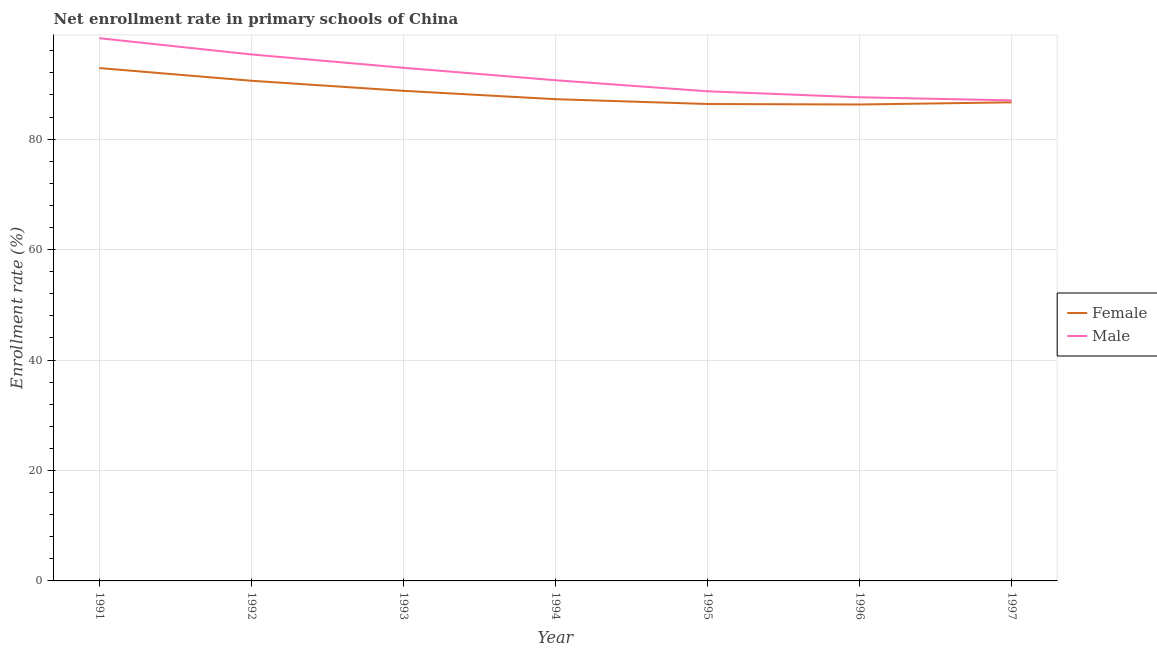How many different coloured lines are there?
Your response must be concise. 2. Does the line corresponding to enrollment rate of female students intersect with the line corresponding to enrollment rate of male students?
Give a very brief answer. No. What is the enrollment rate of female students in 1991?
Keep it short and to the point. 92.88. Across all years, what is the maximum enrollment rate of male students?
Your response must be concise. 98.29. Across all years, what is the minimum enrollment rate of female students?
Keep it short and to the point. 86.28. In which year was the enrollment rate of male students maximum?
Give a very brief answer. 1991. What is the total enrollment rate of female students in the graph?
Offer a very short reply. 618.77. What is the difference between the enrollment rate of female students in 1994 and that in 1996?
Provide a succinct answer. 0.97. What is the difference between the enrollment rate of male students in 1994 and the enrollment rate of female students in 1997?
Your answer should be very brief. 4. What is the average enrollment rate of male students per year?
Make the answer very short. 91.5. In the year 1996, what is the difference between the enrollment rate of female students and enrollment rate of male students?
Your answer should be very brief. -1.31. In how many years, is the enrollment rate of female students greater than 48 %?
Your answer should be very brief. 7. What is the ratio of the enrollment rate of female students in 1991 to that in 1992?
Your answer should be very brief. 1.03. Is the enrollment rate of female students in 1996 less than that in 1997?
Give a very brief answer. Yes. Is the difference between the enrollment rate of male students in 1991 and 1995 greater than the difference between the enrollment rate of female students in 1991 and 1995?
Your answer should be very brief. Yes. What is the difference between the highest and the second highest enrollment rate of female students?
Provide a succinct answer. 2.3. What is the difference between the highest and the lowest enrollment rate of female students?
Your answer should be compact. 6.6. In how many years, is the enrollment rate of male students greater than the average enrollment rate of male students taken over all years?
Make the answer very short. 3. Is the sum of the enrollment rate of male students in 1993 and 1996 greater than the maximum enrollment rate of female students across all years?
Provide a short and direct response. Yes. Does the enrollment rate of male students monotonically increase over the years?
Make the answer very short. No. Is the enrollment rate of female students strictly greater than the enrollment rate of male students over the years?
Your answer should be compact. No. How many lines are there?
Ensure brevity in your answer.  2. How many years are there in the graph?
Your answer should be very brief. 7. What is the difference between two consecutive major ticks on the Y-axis?
Your response must be concise. 20. Does the graph contain grids?
Provide a short and direct response. Yes. How are the legend labels stacked?
Keep it short and to the point. Vertical. What is the title of the graph?
Your answer should be very brief. Net enrollment rate in primary schools of China. Does "Highest 10% of population" appear as one of the legend labels in the graph?
Give a very brief answer. No. What is the label or title of the X-axis?
Your answer should be very brief. Year. What is the label or title of the Y-axis?
Give a very brief answer. Enrollment rate (%). What is the Enrollment rate (%) of Female in 1991?
Make the answer very short. 92.88. What is the Enrollment rate (%) in Male in 1991?
Give a very brief answer. 98.29. What is the Enrollment rate (%) of Female in 1992?
Make the answer very short. 90.58. What is the Enrollment rate (%) of Male in 1992?
Provide a succinct answer. 95.34. What is the Enrollment rate (%) in Female in 1993?
Your answer should be compact. 88.75. What is the Enrollment rate (%) in Male in 1993?
Offer a very short reply. 92.93. What is the Enrollment rate (%) of Female in 1994?
Your response must be concise. 87.24. What is the Enrollment rate (%) in Male in 1994?
Make the answer very short. 90.67. What is the Enrollment rate (%) in Female in 1995?
Offer a terse response. 86.37. What is the Enrollment rate (%) in Male in 1995?
Give a very brief answer. 88.67. What is the Enrollment rate (%) of Female in 1996?
Make the answer very short. 86.28. What is the Enrollment rate (%) in Male in 1996?
Offer a terse response. 87.58. What is the Enrollment rate (%) in Female in 1997?
Make the answer very short. 86.67. What is the Enrollment rate (%) in Male in 1997?
Make the answer very short. 87.02. Across all years, what is the maximum Enrollment rate (%) in Female?
Make the answer very short. 92.88. Across all years, what is the maximum Enrollment rate (%) of Male?
Ensure brevity in your answer.  98.29. Across all years, what is the minimum Enrollment rate (%) of Female?
Give a very brief answer. 86.28. Across all years, what is the minimum Enrollment rate (%) in Male?
Offer a terse response. 87.02. What is the total Enrollment rate (%) of Female in the graph?
Your answer should be very brief. 618.77. What is the total Enrollment rate (%) of Male in the graph?
Keep it short and to the point. 640.51. What is the difference between the Enrollment rate (%) in Female in 1991 and that in 1992?
Keep it short and to the point. 2.3. What is the difference between the Enrollment rate (%) of Male in 1991 and that in 1992?
Make the answer very short. 2.94. What is the difference between the Enrollment rate (%) of Female in 1991 and that in 1993?
Offer a terse response. 4.12. What is the difference between the Enrollment rate (%) of Male in 1991 and that in 1993?
Offer a very short reply. 5.36. What is the difference between the Enrollment rate (%) of Female in 1991 and that in 1994?
Offer a terse response. 5.64. What is the difference between the Enrollment rate (%) in Male in 1991 and that in 1994?
Your answer should be very brief. 7.61. What is the difference between the Enrollment rate (%) in Female in 1991 and that in 1995?
Ensure brevity in your answer.  6.51. What is the difference between the Enrollment rate (%) in Male in 1991 and that in 1995?
Ensure brevity in your answer.  9.61. What is the difference between the Enrollment rate (%) in Female in 1991 and that in 1996?
Offer a very short reply. 6.6. What is the difference between the Enrollment rate (%) of Male in 1991 and that in 1996?
Make the answer very short. 10.7. What is the difference between the Enrollment rate (%) of Female in 1991 and that in 1997?
Provide a succinct answer. 6.21. What is the difference between the Enrollment rate (%) in Male in 1991 and that in 1997?
Provide a succinct answer. 11.26. What is the difference between the Enrollment rate (%) in Female in 1992 and that in 1993?
Give a very brief answer. 1.82. What is the difference between the Enrollment rate (%) of Male in 1992 and that in 1993?
Provide a succinct answer. 2.42. What is the difference between the Enrollment rate (%) in Female in 1992 and that in 1994?
Offer a very short reply. 3.33. What is the difference between the Enrollment rate (%) in Male in 1992 and that in 1994?
Give a very brief answer. 4.67. What is the difference between the Enrollment rate (%) of Female in 1992 and that in 1995?
Provide a succinct answer. 4.21. What is the difference between the Enrollment rate (%) in Male in 1992 and that in 1995?
Provide a short and direct response. 6.67. What is the difference between the Enrollment rate (%) of Female in 1992 and that in 1996?
Give a very brief answer. 4.3. What is the difference between the Enrollment rate (%) of Male in 1992 and that in 1996?
Your response must be concise. 7.76. What is the difference between the Enrollment rate (%) in Female in 1992 and that in 1997?
Your answer should be very brief. 3.91. What is the difference between the Enrollment rate (%) of Male in 1992 and that in 1997?
Your answer should be compact. 8.32. What is the difference between the Enrollment rate (%) of Female in 1993 and that in 1994?
Offer a terse response. 1.51. What is the difference between the Enrollment rate (%) in Male in 1993 and that in 1994?
Give a very brief answer. 2.25. What is the difference between the Enrollment rate (%) in Female in 1993 and that in 1995?
Provide a short and direct response. 2.39. What is the difference between the Enrollment rate (%) in Male in 1993 and that in 1995?
Your answer should be compact. 4.25. What is the difference between the Enrollment rate (%) in Female in 1993 and that in 1996?
Your answer should be compact. 2.48. What is the difference between the Enrollment rate (%) of Male in 1993 and that in 1996?
Ensure brevity in your answer.  5.34. What is the difference between the Enrollment rate (%) in Female in 1993 and that in 1997?
Keep it short and to the point. 2.08. What is the difference between the Enrollment rate (%) of Male in 1993 and that in 1997?
Provide a short and direct response. 5.9. What is the difference between the Enrollment rate (%) of Female in 1994 and that in 1995?
Give a very brief answer. 0.88. What is the difference between the Enrollment rate (%) of Male in 1994 and that in 1995?
Give a very brief answer. 2. What is the difference between the Enrollment rate (%) in Female in 1994 and that in 1996?
Offer a terse response. 0.97. What is the difference between the Enrollment rate (%) of Male in 1994 and that in 1996?
Your answer should be compact. 3.09. What is the difference between the Enrollment rate (%) of Female in 1994 and that in 1997?
Provide a short and direct response. 0.57. What is the difference between the Enrollment rate (%) of Male in 1994 and that in 1997?
Give a very brief answer. 3.65. What is the difference between the Enrollment rate (%) of Female in 1995 and that in 1996?
Give a very brief answer. 0.09. What is the difference between the Enrollment rate (%) of Male in 1995 and that in 1996?
Provide a succinct answer. 1.09. What is the difference between the Enrollment rate (%) in Female in 1995 and that in 1997?
Make the answer very short. -0.3. What is the difference between the Enrollment rate (%) in Male in 1995 and that in 1997?
Your answer should be compact. 1.65. What is the difference between the Enrollment rate (%) in Female in 1996 and that in 1997?
Your answer should be compact. -0.39. What is the difference between the Enrollment rate (%) in Male in 1996 and that in 1997?
Your answer should be compact. 0.56. What is the difference between the Enrollment rate (%) of Female in 1991 and the Enrollment rate (%) of Male in 1992?
Your answer should be very brief. -2.46. What is the difference between the Enrollment rate (%) of Female in 1991 and the Enrollment rate (%) of Male in 1993?
Ensure brevity in your answer.  -0.05. What is the difference between the Enrollment rate (%) in Female in 1991 and the Enrollment rate (%) in Male in 1994?
Give a very brief answer. 2.21. What is the difference between the Enrollment rate (%) in Female in 1991 and the Enrollment rate (%) in Male in 1995?
Provide a succinct answer. 4.21. What is the difference between the Enrollment rate (%) in Female in 1991 and the Enrollment rate (%) in Male in 1996?
Make the answer very short. 5.29. What is the difference between the Enrollment rate (%) in Female in 1991 and the Enrollment rate (%) in Male in 1997?
Give a very brief answer. 5.85. What is the difference between the Enrollment rate (%) in Female in 1992 and the Enrollment rate (%) in Male in 1993?
Your answer should be compact. -2.35. What is the difference between the Enrollment rate (%) of Female in 1992 and the Enrollment rate (%) of Male in 1994?
Offer a terse response. -0.1. What is the difference between the Enrollment rate (%) in Female in 1992 and the Enrollment rate (%) in Male in 1995?
Your answer should be compact. 1.91. What is the difference between the Enrollment rate (%) in Female in 1992 and the Enrollment rate (%) in Male in 1996?
Your answer should be very brief. 2.99. What is the difference between the Enrollment rate (%) of Female in 1992 and the Enrollment rate (%) of Male in 1997?
Give a very brief answer. 3.55. What is the difference between the Enrollment rate (%) of Female in 1993 and the Enrollment rate (%) of Male in 1994?
Offer a terse response. -1.92. What is the difference between the Enrollment rate (%) of Female in 1993 and the Enrollment rate (%) of Male in 1995?
Offer a terse response. 0.08. What is the difference between the Enrollment rate (%) in Female in 1993 and the Enrollment rate (%) in Male in 1996?
Give a very brief answer. 1.17. What is the difference between the Enrollment rate (%) in Female in 1993 and the Enrollment rate (%) in Male in 1997?
Make the answer very short. 1.73. What is the difference between the Enrollment rate (%) in Female in 1994 and the Enrollment rate (%) in Male in 1995?
Provide a short and direct response. -1.43. What is the difference between the Enrollment rate (%) in Female in 1994 and the Enrollment rate (%) in Male in 1996?
Your answer should be very brief. -0.34. What is the difference between the Enrollment rate (%) in Female in 1994 and the Enrollment rate (%) in Male in 1997?
Provide a short and direct response. 0.22. What is the difference between the Enrollment rate (%) of Female in 1995 and the Enrollment rate (%) of Male in 1996?
Your answer should be compact. -1.22. What is the difference between the Enrollment rate (%) in Female in 1995 and the Enrollment rate (%) in Male in 1997?
Give a very brief answer. -0.66. What is the difference between the Enrollment rate (%) of Female in 1996 and the Enrollment rate (%) of Male in 1997?
Offer a very short reply. -0.75. What is the average Enrollment rate (%) of Female per year?
Give a very brief answer. 88.4. What is the average Enrollment rate (%) in Male per year?
Make the answer very short. 91.5. In the year 1991, what is the difference between the Enrollment rate (%) in Female and Enrollment rate (%) in Male?
Your answer should be very brief. -5.41. In the year 1992, what is the difference between the Enrollment rate (%) of Female and Enrollment rate (%) of Male?
Provide a succinct answer. -4.76. In the year 1993, what is the difference between the Enrollment rate (%) in Female and Enrollment rate (%) in Male?
Make the answer very short. -4.17. In the year 1994, what is the difference between the Enrollment rate (%) of Female and Enrollment rate (%) of Male?
Offer a terse response. -3.43. In the year 1995, what is the difference between the Enrollment rate (%) of Female and Enrollment rate (%) of Male?
Ensure brevity in your answer.  -2.3. In the year 1996, what is the difference between the Enrollment rate (%) in Female and Enrollment rate (%) in Male?
Offer a very short reply. -1.31. In the year 1997, what is the difference between the Enrollment rate (%) of Female and Enrollment rate (%) of Male?
Your answer should be compact. -0.35. What is the ratio of the Enrollment rate (%) of Female in 1991 to that in 1992?
Your answer should be compact. 1.03. What is the ratio of the Enrollment rate (%) in Male in 1991 to that in 1992?
Ensure brevity in your answer.  1.03. What is the ratio of the Enrollment rate (%) of Female in 1991 to that in 1993?
Provide a succinct answer. 1.05. What is the ratio of the Enrollment rate (%) in Male in 1991 to that in 1993?
Your response must be concise. 1.06. What is the ratio of the Enrollment rate (%) in Female in 1991 to that in 1994?
Offer a very short reply. 1.06. What is the ratio of the Enrollment rate (%) in Male in 1991 to that in 1994?
Provide a short and direct response. 1.08. What is the ratio of the Enrollment rate (%) in Female in 1991 to that in 1995?
Offer a very short reply. 1.08. What is the ratio of the Enrollment rate (%) in Male in 1991 to that in 1995?
Ensure brevity in your answer.  1.11. What is the ratio of the Enrollment rate (%) in Female in 1991 to that in 1996?
Offer a terse response. 1.08. What is the ratio of the Enrollment rate (%) of Male in 1991 to that in 1996?
Your answer should be very brief. 1.12. What is the ratio of the Enrollment rate (%) of Female in 1991 to that in 1997?
Your answer should be compact. 1.07. What is the ratio of the Enrollment rate (%) in Male in 1991 to that in 1997?
Your response must be concise. 1.13. What is the ratio of the Enrollment rate (%) of Female in 1992 to that in 1993?
Provide a succinct answer. 1.02. What is the ratio of the Enrollment rate (%) of Male in 1992 to that in 1993?
Provide a succinct answer. 1.03. What is the ratio of the Enrollment rate (%) in Female in 1992 to that in 1994?
Give a very brief answer. 1.04. What is the ratio of the Enrollment rate (%) in Male in 1992 to that in 1994?
Ensure brevity in your answer.  1.05. What is the ratio of the Enrollment rate (%) of Female in 1992 to that in 1995?
Provide a short and direct response. 1.05. What is the ratio of the Enrollment rate (%) of Male in 1992 to that in 1995?
Your response must be concise. 1.08. What is the ratio of the Enrollment rate (%) of Female in 1992 to that in 1996?
Give a very brief answer. 1.05. What is the ratio of the Enrollment rate (%) of Male in 1992 to that in 1996?
Offer a very short reply. 1.09. What is the ratio of the Enrollment rate (%) of Female in 1992 to that in 1997?
Ensure brevity in your answer.  1.05. What is the ratio of the Enrollment rate (%) of Male in 1992 to that in 1997?
Provide a short and direct response. 1.1. What is the ratio of the Enrollment rate (%) in Female in 1993 to that in 1994?
Offer a very short reply. 1.02. What is the ratio of the Enrollment rate (%) in Male in 1993 to that in 1994?
Provide a succinct answer. 1.02. What is the ratio of the Enrollment rate (%) in Female in 1993 to that in 1995?
Make the answer very short. 1.03. What is the ratio of the Enrollment rate (%) of Male in 1993 to that in 1995?
Your answer should be very brief. 1.05. What is the ratio of the Enrollment rate (%) of Female in 1993 to that in 1996?
Ensure brevity in your answer.  1.03. What is the ratio of the Enrollment rate (%) of Male in 1993 to that in 1996?
Your answer should be very brief. 1.06. What is the ratio of the Enrollment rate (%) of Female in 1993 to that in 1997?
Ensure brevity in your answer.  1.02. What is the ratio of the Enrollment rate (%) of Male in 1993 to that in 1997?
Ensure brevity in your answer.  1.07. What is the ratio of the Enrollment rate (%) in Male in 1994 to that in 1995?
Ensure brevity in your answer.  1.02. What is the ratio of the Enrollment rate (%) of Female in 1994 to that in 1996?
Offer a very short reply. 1.01. What is the ratio of the Enrollment rate (%) in Male in 1994 to that in 1996?
Ensure brevity in your answer.  1.04. What is the ratio of the Enrollment rate (%) in Female in 1994 to that in 1997?
Give a very brief answer. 1.01. What is the ratio of the Enrollment rate (%) in Male in 1994 to that in 1997?
Provide a short and direct response. 1.04. What is the ratio of the Enrollment rate (%) of Male in 1995 to that in 1996?
Offer a very short reply. 1.01. What is the ratio of the Enrollment rate (%) of Male in 1995 to that in 1997?
Keep it short and to the point. 1.02. What is the ratio of the Enrollment rate (%) of Male in 1996 to that in 1997?
Your answer should be very brief. 1.01. What is the difference between the highest and the second highest Enrollment rate (%) of Female?
Keep it short and to the point. 2.3. What is the difference between the highest and the second highest Enrollment rate (%) in Male?
Your answer should be compact. 2.94. What is the difference between the highest and the lowest Enrollment rate (%) of Female?
Offer a terse response. 6.6. What is the difference between the highest and the lowest Enrollment rate (%) of Male?
Your answer should be very brief. 11.26. 